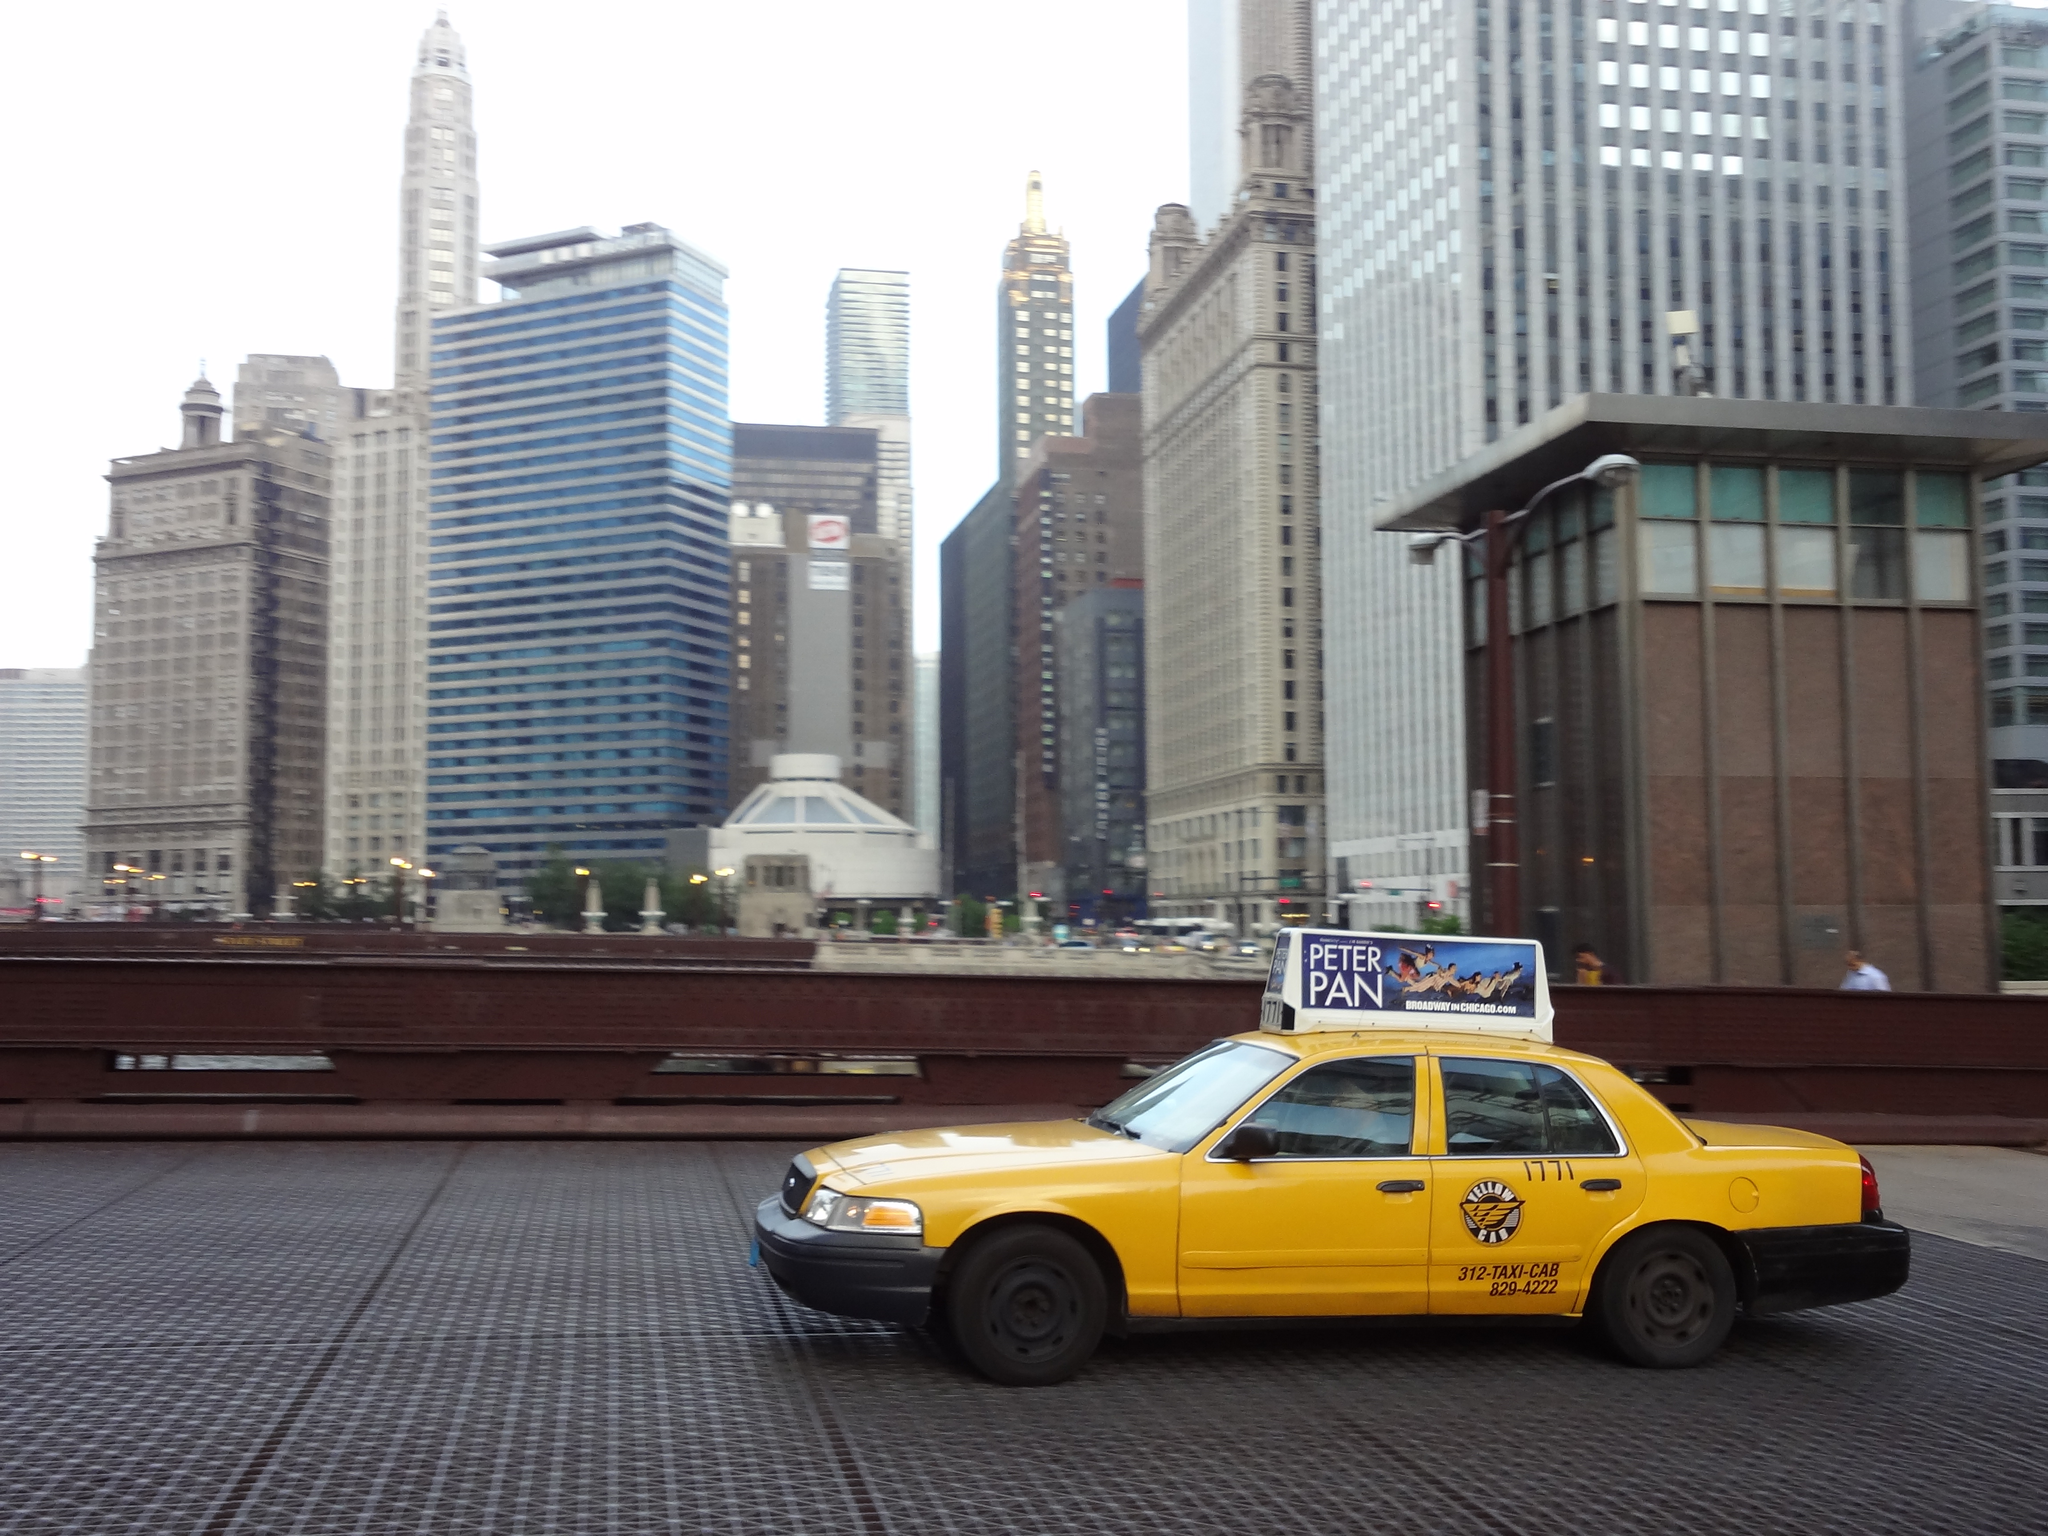<image>
Summarize the visual content of the image. a taxi cab that is sitting on the street 